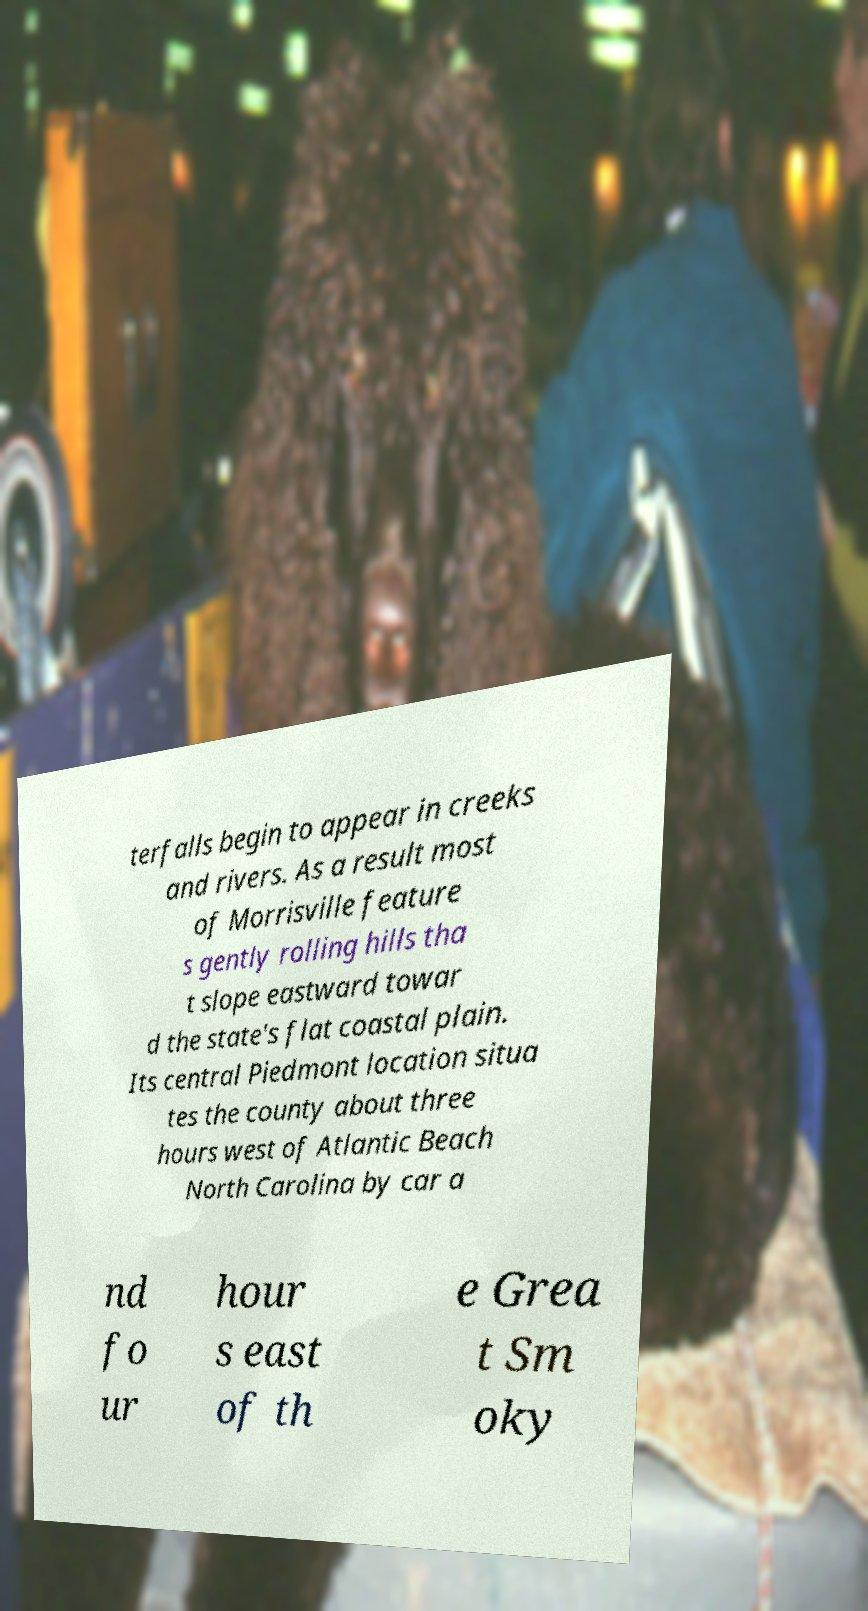Please identify and transcribe the text found in this image. terfalls begin to appear in creeks and rivers. As a result most of Morrisville feature s gently rolling hills tha t slope eastward towar d the state's flat coastal plain. Its central Piedmont location situa tes the county about three hours west of Atlantic Beach North Carolina by car a nd fo ur hour s east of th e Grea t Sm oky 